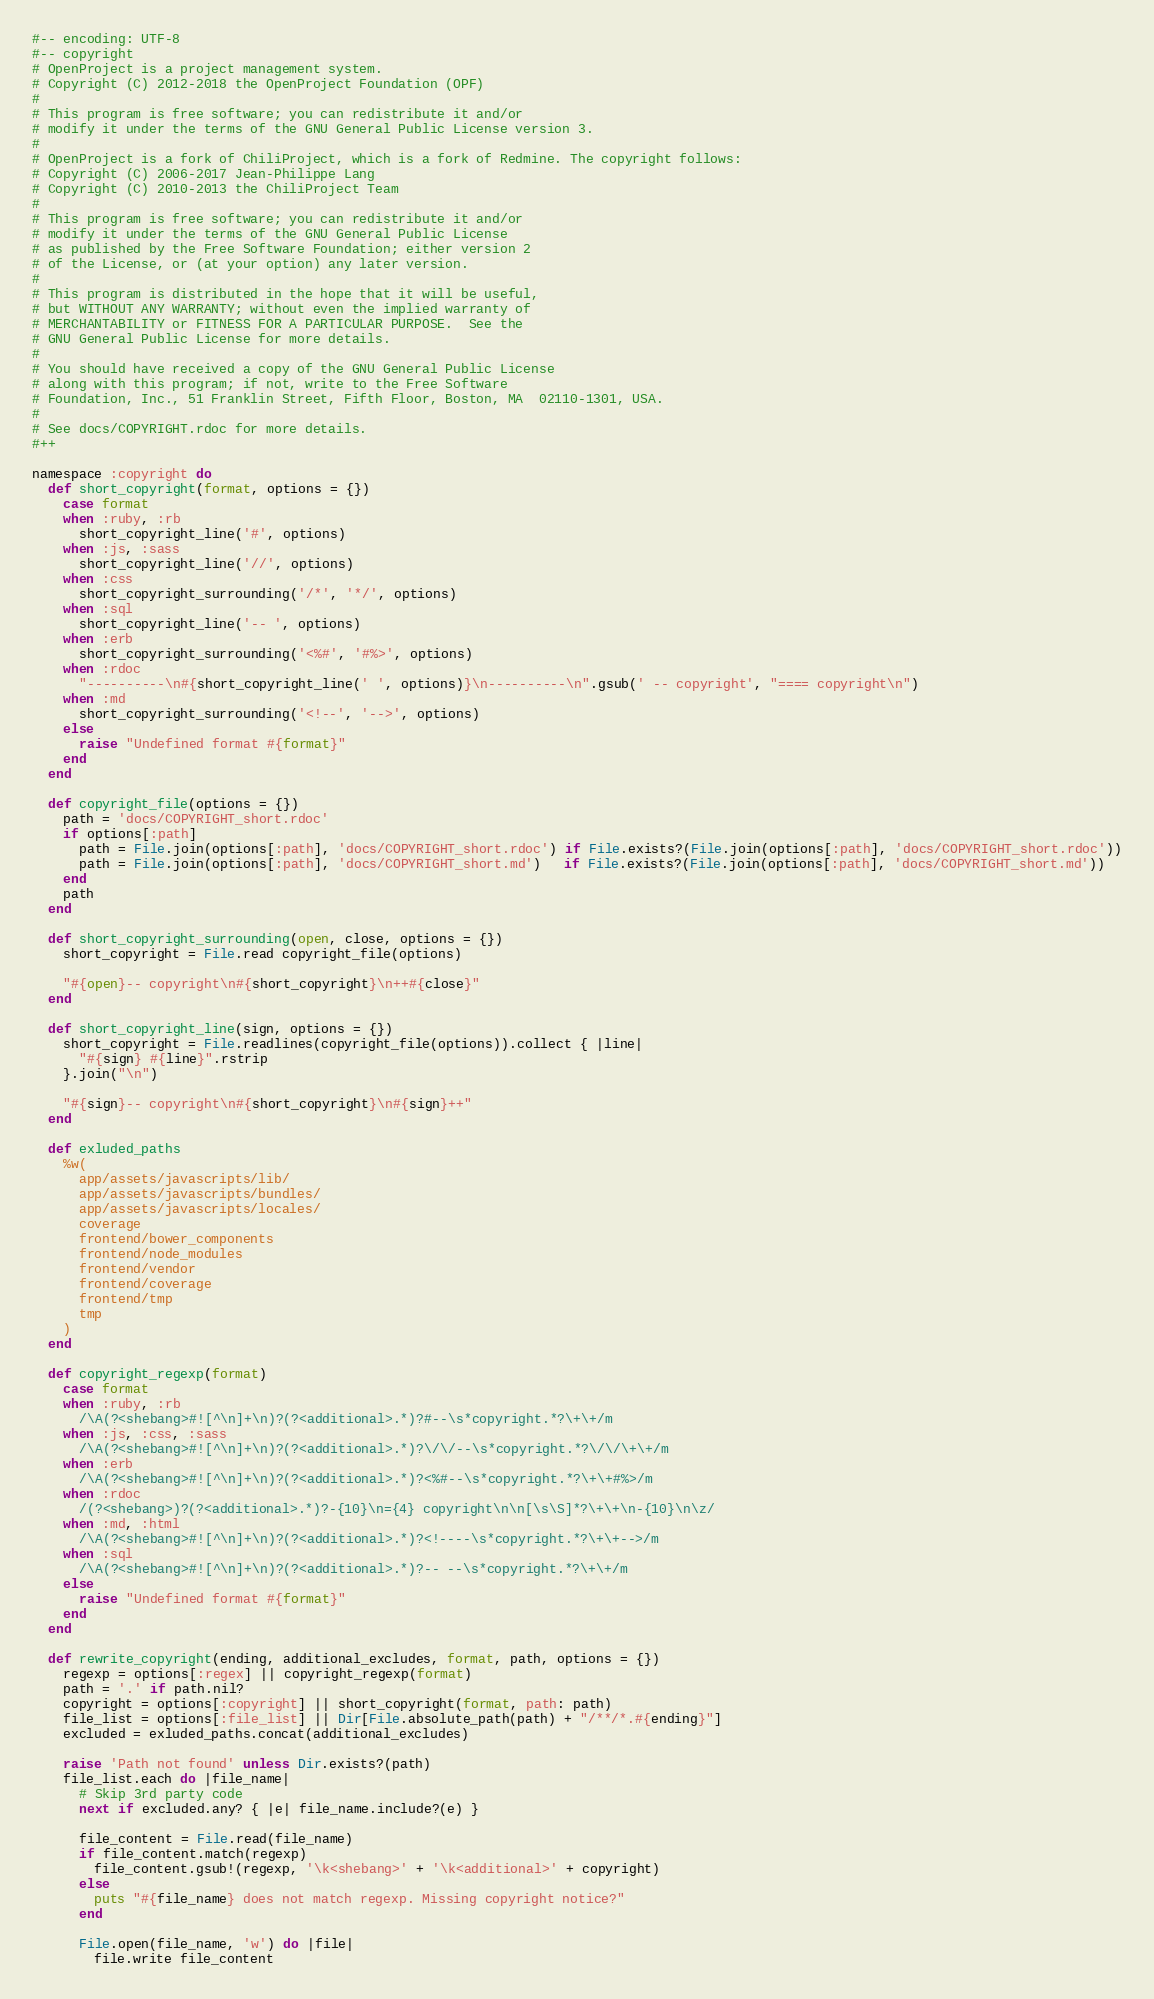Convert code to text. <code><loc_0><loc_0><loc_500><loc_500><_Ruby_>#-- encoding: UTF-8
#-- copyright
# OpenProject is a project management system.
# Copyright (C) 2012-2018 the OpenProject Foundation (OPF)
#
# This program is free software; you can redistribute it and/or
# modify it under the terms of the GNU General Public License version 3.
#
# OpenProject is a fork of ChiliProject, which is a fork of Redmine. The copyright follows:
# Copyright (C) 2006-2017 Jean-Philippe Lang
# Copyright (C) 2010-2013 the ChiliProject Team
#
# This program is free software; you can redistribute it and/or
# modify it under the terms of the GNU General Public License
# as published by the Free Software Foundation; either version 2
# of the License, or (at your option) any later version.
#
# This program is distributed in the hope that it will be useful,
# but WITHOUT ANY WARRANTY; without even the implied warranty of
# MERCHANTABILITY or FITNESS FOR A PARTICULAR PURPOSE.  See the
# GNU General Public License for more details.
#
# You should have received a copy of the GNU General Public License
# along with this program; if not, write to the Free Software
# Foundation, Inc., 51 Franklin Street, Fifth Floor, Boston, MA  02110-1301, USA.
#
# See docs/COPYRIGHT.rdoc for more details.
#++

namespace :copyright do
  def short_copyright(format, options = {})
    case format
    when :ruby, :rb
      short_copyright_line('#', options)
    when :js, :sass
      short_copyright_line('//', options)
    when :css
      short_copyright_surrounding('/*', '*/', options)
    when :sql
      short_copyright_line('-- ', options)
    when :erb
      short_copyright_surrounding('<%#', '#%>', options)
    when :rdoc
      "----------\n#{short_copyright_line(' ', options)}\n----------\n".gsub(' -- copyright', "==== copyright\n")
    when :md
      short_copyright_surrounding('<!--', '-->', options)
    else
      raise "Undefined format #{format}"
    end
  end

  def copyright_file(options = {})
    path = 'docs/COPYRIGHT_short.rdoc'
    if options[:path]
      path = File.join(options[:path], 'docs/COPYRIGHT_short.rdoc') if File.exists?(File.join(options[:path], 'docs/COPYRIGHT_short.rdoc'))
      path = File.join(options[:path], 'docs/COPYRIGHT_short.md')   if File.exists?(File.join(options[:path], 'docs/COPYRIGHT_short.md'))
    end
    path
  end

  def short_copyright_surrounding(open, close, options = {})
    short_copyright = File.read copyright_file(options)

    "#{open}-- copyright\n#{short_copyright}\n++#{close}"
  end

  def short_copyright_line(sign, options = {})
    short_copyright = File.readlines(copyright_file(options)).collect { |line|
      "#{sign} #{line}".rstrip
    }.join("\n")

    "#{sign}-- copyright\n#{short_copyright}\n#{sign}++"
  end

  def exluded_paths
    %w(
      app/assets/javascripts/lib/
      app/assets/javascripts/bundles/
      app/assets/javascripts/locales/
      coverage
      frontend/bower_components
      frontend/node_modules
      frontend/vendor
      frontend/coverage
      frontend/tmp
      tmp
    )
  end

  def copyright_regexp(format)
    case format
    when :ruby, :rb
      /\A(?<shebang>#![^\n]+\n)?(?<additional>.*)?#--\s*copyright.*?\+\+/m
    when :js, :css, :sass
      /\A(?<shebang>#![^\n]+\n)?(?<additional>.*)?\/\/--\s*copyright.*?\/\/\+\+/m
    when :erb
      /\A(?<shebang>#![^\n]+\n)?(?<additional>.*)?<%#--\s*copyright.*?\+\+#%>/m
    when :rdoc
      /(?<shebang>)?(?<additional>.*)?-{10}\n={4} copyright\n\n[\s\S]*?\+\+\n-{10}\n\z/
    when :md, :html
      /\A(?<shebang>#![^\n]+\n)?(?<additional>.*)?<!----\s*copyright.*?\+\+-->/m
    when :sql
      /\A(?<shebang>#![^\n]+\n)?(?<additional>.*)?-- --\s*copyright.*?\+\+/m
    else
      raise "Undefined format #{format}"
    end
  end

  def rewrite_copyright(ending, additional_excludes, format, path, options = {})
    regexp = options[:regex] || copyright_regexp(format)
    path = '.' if path.nil?
    copyright = options[:copyright] || short_copyright(format, path: path)
    file_list = options[:file_list] || Dir[File.absolute_path(path) + "/**/*.#{ending}"]
    excluded = exluded_paths.concat(additional_excludes)

    raise 'Path not found' unless Dir.exists?(path)
    file_list.each do |file_name|
      # Skip 3rd party code
      next if excluded.any? { |e| file_name.include?(e) }

      file_content = File.read(file_name)
      if file_content.match(regexp)
        file_content.gsub!(regexp, '\k<shebang>' + '\k<additional>' + copyright)
      else
        puts "#{file_name} does not match regexp. Missing copyright notice?"
      end

      File.open(file_name, 'w') do |file|
        file.write file_content</code> 